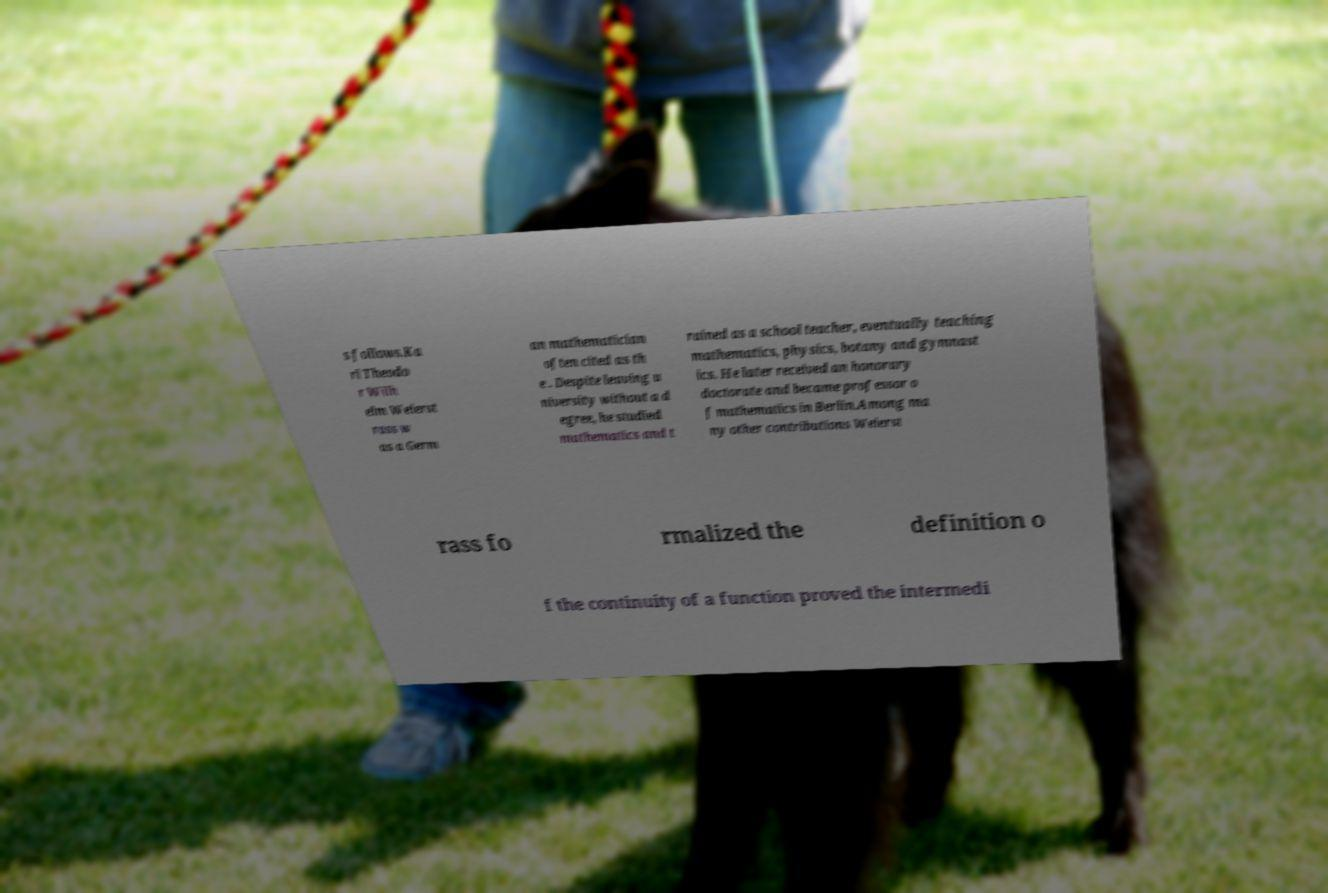What messages or text are displayed in this image? I need them in a readable, typed format. s follows.Ka rl Theodo r Wilh elm Weierst rass w as a Germ an mathematician often cited as th e . Despite leaving u niversity without a d egree, he studied mathematics and t rained as a school teacher, eventually teaching mathematics, physics, botany and gymnast ics. He later received an honorary doctorate and became professor o f mathematics in Berlin.Among ma ny other contributions Weierst rass fo rmalized the definition o f the continuity of a function proved the intermedi 